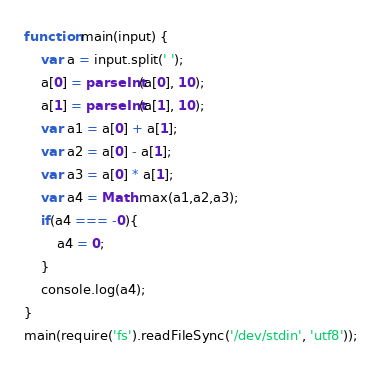Convert code to text. <code><loc_0><loc_0><loc_500><loc_500><_JavaScript_>function main(input) {
	var a = input.split(' ');
	a[0] = parseInt(a[0], 10);
	a[1] = parseInt(a[1], 10);
	var a1 = a[0] + a[1];
	var a2 = a[0] - a[1];
	var a3 = a[0] * a[1];
	var a4 = Math.max(a1,a2,a3);
	if(a4 === -0){
		a4 = 0;
	}
	console.log(a4);
}
main(require('fs').readFileSync('/dev/stdin', 'utf8'));</code> 